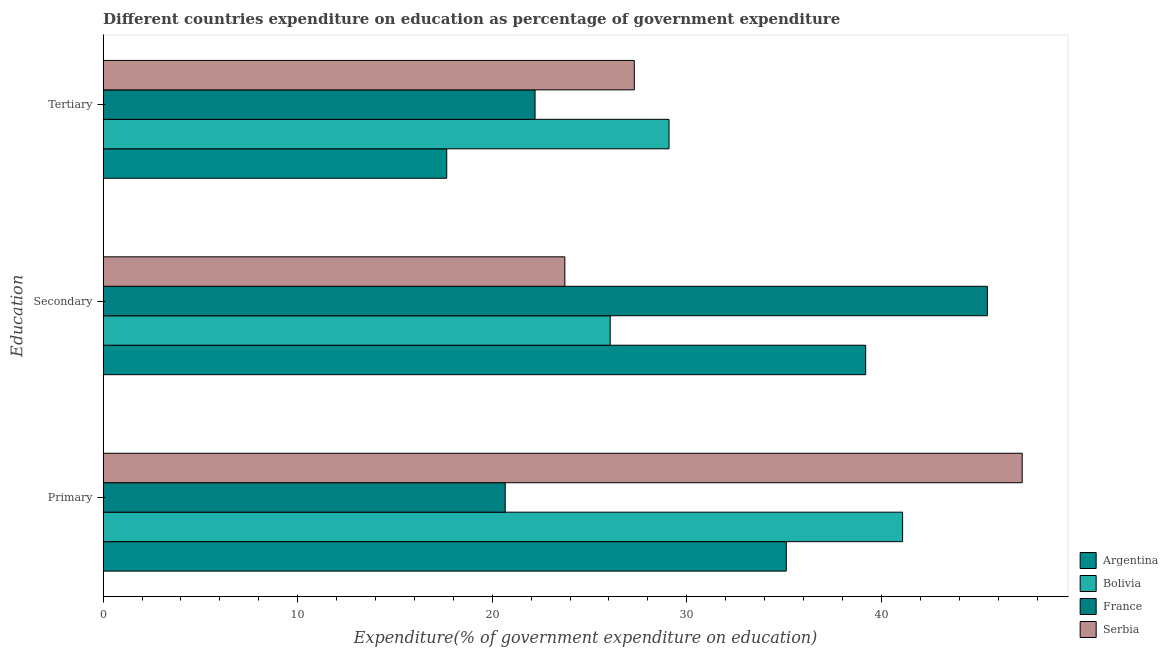Are the number of bars per tick equal to the number of legend labels?
Your answer should be very brief. Yes. How many bars are there on the 1st tick from the top?
Make the answer very short. 4. How many bars are there on the 2nd tick from the bottom?
Offer a very short reply. 4. What is the label of the 3rd group of bars from the top?
Your answer should be compact. Primary. What is the expenditure on secondary education in Serbia?
Ensure brevity in your answer.  23.73. Across all countries, what is the maximum expenditure on tertiary education?
Make the answer very short. 29.09. Across all countries, what is the minimum expenditure on primary education?
Provide a short and direct response. 20.67. What is the total expenditure on secondary education in the graph?
Offer a very short reply. 134.44. What is the difference between the expenditure on tertiary education in Serbia and that in Bolivia?
Offer a very short reply. -1.79. What is the difference between the expenditure on tertiary education in Argentina and the expenditure on primary education in France?
Provide a succinct answer. -3.01. What is the average expenditure on primary education per country?
Ensure brevity in your answer.  36.03. What is the difference between the expenditure on primary education and expenditure on tertiary education in Serbia?
Make the answer very short. 19.94. In how many countries, is the expenditure on primary education greater than 4 %?
Offer a very short reply. 4. What is the ratio of the expenditure on secondary education in Argentina to that in France?
Ensure brevity in your answer.  0.86. Is the difference between the expenditure on primary education in Serbia and France greater than the difference between the expenditure on tertiary education in Serbia and France?
Your response must be concise. Yes. What is the difference between the highest and the second highest expenditure on primary education?
Offer a very short reply. 6.15. What is the difference between the highest and the lowest expenditure on secondary education?
Provide a succinct answer. 21.72. In how many countries, is the expenditure on secondary education greater than the average expenditure on secondary education taken over all countries?
Your answer should be compact. 2. Is the sum of the expenditure on primary education in Bolivia and Argentina greater than the maximum expenditure on tertiary education across all countries?
Offer a very short reply. Yes. How many bars are there?
Your answer should be compact. 12. Are all the bars in the graph horizontal?
Make the answer very short. Yes. How many countries are there in the graph?
Your response must be concise. 4. Are the values on the major ticks of X-axis written in scientific E-notation?
Your response must be concise. No. Where does the legend appear in the graph?
Your answer should be very brief. Bottom right. What is the title of the graph?
Keep it short and to the point. Different countries expenditure on education as percentage of government expenditure. Does "Malaysia" appear as one of the legend labels in the graph?
Ensure brevity in your answer.  No. What is the label or title of the X-axis?
Offer a very short reply. Expenditure(% of government expenditure on education). What is the label or title of the Y-axis?
Make the answer very short. Education. What is the Expenditure(% of government expenditure on education) of Argentina in Primary?
Make the answer very short. 35.11. What is the Expenditure(% of government expenditure on education) in Bolivia in Primary?
Give a very brief answer. 41.09. What is the Expenditure(% of government expenditure on education) of France in Primary?
Your response must be concise. 20.67. What is the Expenditure(% of government expenditure on education) of Serbia in Primary?
Keep it short and to the point. 47.24. What is the Expenditure(% of government expenditure on education) in Argentina in Secondary?
Make the answer very short. 39.19. What is the Expenditure(% of government expenditure on education) in Bolivia in Secondary?
Your answer should be compact. 26.06. What is the Expenditure(% of government expenditure on education) in France in Secondary?
Offer a terse response. 45.45. What is the Expenditure(% of government expenditure on education) of Serbia in Secondary?
Ensure brevity in your answer.  23.73. What is the Expenditure(% of government expenditure on education) in Argentina in Tertiary?
Provide a succinct answer. 17.66. What is the Expenditure(% of government expenditure on education) of Bolivia in Tertiary?
Your answer should be compact. 29.09. What is the Expenditure(% of government expenditure on education) in France in Tertiary?
Offer a terse response. 22.2. What is the Expenditure(% of government expenditure on education) in Serbia in Tertiary?
Provide a short and direct response. 27.3. Across all Education, what is the maximum Expenditure(% of government expenditure on education) in Argentina?
Your response must be concise. 39.19. Across all Education, what is the maximum Expenditure(% of government expenditure on education) in Bolivia?
Your response must be concise. 41.09. Across all Education, what is the maximum Expenditure(% of government expenditure on education) of France?
Your answer should be very brief. 45.45. Across all Education, what is the maximum Expenditure(% of government expenditure on education) of Serbia?
Ensure brevity in your answer.  47.24. Across all Education, what is the minimum Expenditure(% of government expenditure on education) in Argentina?
Your answer should be very brief. 17.66. Across all Education, what is the minimum Expenditure(% of government expenditure on education) in Bolivia?
Provide a short and direct response. 26.06. Across all Education, what is the minimum Expenditure(% of government expenditure on education) in France?
Your answer should be very brief. 20.67. Across all Education, what is the minimum Expenditure(% of government expenditure on education) of Serbia?
Ensure brevity in your answer.  23.73. What is the total Expenditure(% of government expenditure on education) of Argentina in the graph?
Offer a very short reply. 91.97. What is the total Expenditure(% of government expenditure on education) in Bolivia in the graph?
Give a very brief answer. 96.24. What is the total Expenditure(% of government expenditure on education) in France in the graph?
Keep it short and to the point. 88.32. What is the total Expenditure(% of government expenditure on education) of Serbia in the graph?
Ensure brevity in your answer.  98.27. What is the difference between the Expenditure(% of government expenditure on education) of Argentina in Primary and that in Secondary?
Keep it short and to the point. -4.08. What is the difference between the Expenditure(% of government expenditure on education) in Bolivia in Primary and that in Secondary?
Provide a succinct answer. 15.03. What is the difference between the Expenditure(% of government expenditure on education) of France in Primary and that in Secondary?
Give a very brief answer. -24.78. What is the difference between the Expenditure(% of government expenditure on education) in Serbia in Primary and that in Secondary?
Your answer should be very brief. 23.51. What is the difference between the Expenditure(% of government expenditure on education) in Argentina in Primary and that in Tertiary?
Your answer should be very brief. 17.45. What is the difference between the Expenditure(% of government expenditure on education) of Bolivia in Primary and that in Tertiary?
Provide a short and direct response. 12. What is the difference between the Expenditure(% of government expenditure on education) of France in Primary and that in Tertiary?
Your response must be concise. -1.53. What is the difference between the Expenditure(% of government expenditure on education) of Serbia in Primary and that in Tertiary?
Your answer should be very brief. 19.94. What is the difference between the Expenditure(% of government expenditure on education) of Argentina in Secondary and that in Tertiary?
Your answer should be very brief. 21.53. What is the difference between the Expenditure(% of government expenditure on education) of Bolivia in Secondary and that in Tertiary?
Give a very brief answer. -3.02. What is the difference between the Expenditure(% of government expenditure on education) in France in Secondary and that in Tertiary?
Provide a succinct answer. 23.25. What is the difference between the Expenditure(% of government expenditure on education) of Serbia in Secondary and that in Tertiary?
Your answer should be very brief. -3.57. What is the difference between the Expenditure(% of government expenditure on education) in Argentina in Primary and the Expenditure(% of government expenditure on education) in Bolivia in Secondary?
Keep it short and to the point. 9.05. What is the difference between the Expenditure(% of government expenditure on education) in Argentina in Primary and the Expenditure(% of government expenditure on education) in France in Secondary?
Keep it short and to the point. -10.34. What is the difference between the Expenditure(% of government expenditure on education) in Argentina in Primary and the Expenditure(% of government expenditure on education) in Serbia in Secondary?
Ensure brevity in your answer.  11.38. What is the difference between the Expenditure(% of government expenditure on education) in Bolivia in Primary and the Expenditure(% of government expenditure on education) in France in Secondary?
Your response must be concise. -4.36. What is the difference between the Expenditure(% of government expenditure on education) of Bolivia in Primary and the Expenditure(% of government expenditure on education) of Serbia in Secondary?
Provide a succinct answer. 17.36. What is the difference between the Expenditure(% of government expenditure on education) in France in Primary and the Expenditure(% of government expenditure on education) in Serbia in Secondary?
Keep it short and to the point. -3.07. What is the difference between the Expenditure(% of government expenditure on education) in Argentina in Primary and the Expenditure(% of government expenditure on education) in Bolivia in Tertiary?
Make the answer very short. 6.03. What is the difference between the Expenditure(% of government expenditure on education) of Argentina in Primary and the Expenditure(% of government expenditure on education) of France in Tertiary?
Keep it short and to the point. 12.91. What is the difference between the Expenditure(% of government expenditure on education) of Argentina in Primary and the Expenditure(% of government expenditure on education) of Serbia in Tertiary?
Your answer should be very brief. 7.81. What is the difference between the Expenditure(% of government expenditure on education) in Bolivia in Primary and the Expenditure(% of government expenditure on education) in France in Tertiary?
Your answer should be compact. 18.89. What is the difference between the Expenditure(% of government expenditure on education) in Bolivia in Primary and the Expenditure(% of government expenditure on education) in Serbia in Tertiary?
Provide a succinct answer. 13.79. What is the difference between the Expenditure(% of government expenditure on education) in France in Primary and the Expenditure(% of government expenditure on education) in Serbia in Tertiary?
Your answer should be very brief. -6.64. What is the difference between the Expenditure(% of government expenditure on education) of Argentina in Secondary and the Expenditure(% of government expenditure on education) of Bolivia in Tertiary?
Offer a very short reply. 10.11. What is the difference between the Expenditure(% of government expenditure on education) of Argentina in Secondary and the Expenditure(% of government expenditure on education) of France in Tertiary?
Offer a terse response. 16.99. What is the difference between the Expenditure(% of government expenditure on education) of Argentina in Secondary and the Expenditure(% of government expenditure on education) of Serbia in Tertiary?
Provide a succinct answer. 11.89. What is the difference between the Expenditure(% of government expenditure on education) in Bolivia in Secondary and the Expenditure(% of government expenditure on education) in France in Tertiary?
Give a very brief answer. 3.86. What is the difference between the Expenditure(% of government expenditure on education) in Bolivia in Secondary and the Expenditure(% of government expenditure on education) in Serbia in Tertiary?
Provide a succinct answer. -1.24. What is the difference between the Expenditure(% of government expenditure on education) in France in Secondary and the Expenditure(% of government expenditure on education) in Serbia in Tertiary?
Keep it short and to the point. 18.15. What is the average Expenditure(% of government expenditure on education) of Argentina per Education?
Offer a very short reply. 30.66. What is the average Expenditure(% of government expenditure on education) in Bolivia per Education?
Your answer should be very brief. 32.08. What is the average Expenditure(% of government expenditure on education) in France per Education?
Ensure brevity in your answer.  29.44. What is the average Expenditure(% of government expenditure on education) of Serbia per Education?
Give a very brief answer. 32.76. What is the difference between the Expenditure(% of government expenditure on education) of Argentina and Expenditure(% of government expenditure on education) of Bolivia in Primary?
Offer a very short reply. -5.98. What is the difference between the Expenditure(% of government expenditure on education) in Argentina and Expenditure(% of government expenditure on education) in France in Primary?
Your answer should be very brief. 14.45. What is the difference between the Expenditure(% of government expenditure on education) of Argentina and Expenditure(% of government expenditure on education) of Serbia in Primary?
Provide a short and direct response. -12.13. What is the difference between the Expenditure(% of government expenditure on education) in Bolivia and Expenditure(% of government expenditure on education) in France in Primary?
Give a very brief answer. 20.43. What is the difference between the Expenditure(% of government expenditure on education) in Bolivia and Expenditure(% of government expenditure on education) in Serbia in Primary?
Offer a very short reply. -6.15. What is the difference between the Expenditure(% of government expenditure on education) of France and Expenditure(% of government expenditure on education) of Serbia in Primary?
Give a very brief answer. -26.57. What is the difference between the Expenditure(% of government expenditure on education) in Argentina and Expenditure(% of government expenditure on education) in Bolivia in Secondary?
Offer a very short reply. 13.13. What is the difference between the Expenditure(% of government expenditure on education) in Argentina and Expenditure(% of government expenditure on education) in France in Secondary?
Give a very brief answer. -6.26. What is the difference between the Expenditure(% of government expenditure on education) in Argentina and Expenditure(% of government expenditure on education) in Serbia in Secondary?
Ensure brevity in your answer.  15.46. What is the difference between the Expenditure(% of government expenditure on education) in Bolivia and Expenditure(% of government expenditure on education) in France in Secondary?
Make the answer very short. -19.39. What is the difference between the Expenditure(% of government expenditure on education) of Bolivia and Expenditure(% of government expenditure on education) of Serbia in Secondary?
Your answer should be compact. 2.33. What is the difference between the Expenditure(% of government expenditure on education) in France and Expenditure(% of government expenditure on education) in Serbia in Secondary?
Offer a very short reply. 21.72. What is the difference between the Expenditure(% of government expenditure on education) of Argentina and Expenditure(% of government expenditure on education) of Bolivia in Tertiary?
Give a very brief answer. -11.43. What is the difference between the Expenditure(% of government expenditure on education) in Argentina and Expenditure(% of government expenditure on education) in France in Tertiary?
Provide a short and direct response. -4.54. What is the difference between the Expenditure(% of government expenditure on education) of Argentina and Expenditure(% of government expenditure on education) of Serbia in Tertiary?
Make the answer very short. -9.64. What is the difference between the Expenditure(% of government expenditure on education) in Bolivia and Expenditure(% of government expenditure on education) in France in Tertiary?
Provide a succinct answer. 6.89. What is the difference between the Expenditure(% of government expenditure on education) in Bolivia and Expenditure(% of government expenditure on education) in Serbia in Tertiary?
Your response must be concise. 1.79. What is the difference between the Expenditure(% of government expenditure on education) of France and Expenditure(% of government expenditure on education) of Serbia in Tertiary?
Make the answer very short. -5.1. What is the ratio of the Expenditure(% of government expenditure on education) of Argentina in Primary to that in Secondary?
Offer a very short reply. 0.9. What is the ratio of the Expenditure(% of government expenditure on education) in Bolivia in Primary to that in Secondary?
Your answer should be very brief. 1.58. What is the ratio of the Expenditure(% of government expenditure on education) in France in Primary to that in Secondary?
Provide a succinct answer. 0.45. What is the ratio of the Expenditure(% of government expenditure on education) of Serbia in Primary to that in Secondary?
Your response must be concise. 1.99. What is the ratio of the Expenditure(% of government expenditure on education) of Argentina in Primary to that in Tertiary?
Your answer should be compact. 1.99. What is the ratio of the Expenditure(% of government expenditure on education) in Bolivia in Primary to that in Tertiary?
Offer a very short reply. 1.41. What is the ratio of the Expenditure(% of government expenditure on education) of France in Primary to that in Tertiary?
Make the answer very short. 0.93. What is the ratio of the Expenditure(% of government expenditure on education) of Serbia in Primary to that in Tertiary?
Keep it short and to the point. 1.73. What is the ratio of the Expenditure(% of government expenditure on education) in Argentina in Secondary to that in Tertiary?
Your answer should be very brief. 2.22. What is the ratio of the Expenditure(% of government expenditure on education) of Bolivia in Secondary to that in Tertiary?
Make the answer very short. 0.9. What is the ratio of the Expenditure(% of government expenditure on education) of France in Secondary to that in Tertiary?
Your answer should be compact. 2.05. What is the ratio of the Expenditure(% of government expenditure on education) in Serbia in Secondary to that in Tertiary?
Ensure brevity in your answer.  0.87. What is the difference between the highest and the second highest Expenditure(% of government expenditure on education) of Argentina?
Your response must be concise. 4.08. What is the difference between the highest and the second highest Expenditure(% of government expenditure on education) in Bolivia?
Offer a terse response. 12. What is the difference between the highest and the second highest Expenditure(% of government expenditure on education) in France?
Your answer should be compact. 23.25. What is the difference between the highest and the second highest Expenditure(% of government expenditure on education) of Serbia?
Your answer should be very brief. 19.94. What is the difference between the highest and the lowest Expenditure(% of government expenditure on education) of Argentina?
Offer a terse response. 21.53. What is the difference between the highest and the lowest Expenditure(% of government expenditure on education) in Bolivia?
Your response must be concise. 15.03. What is the difference between the highest and the lowest Expenditure(% of government expenditure on education) in France?
Make the answer very short. 24.78. What is the difference between the highest and the lowest Expenditure(% of government expenditure on education) in Serbia?
Make the answer very short. 23.51. 